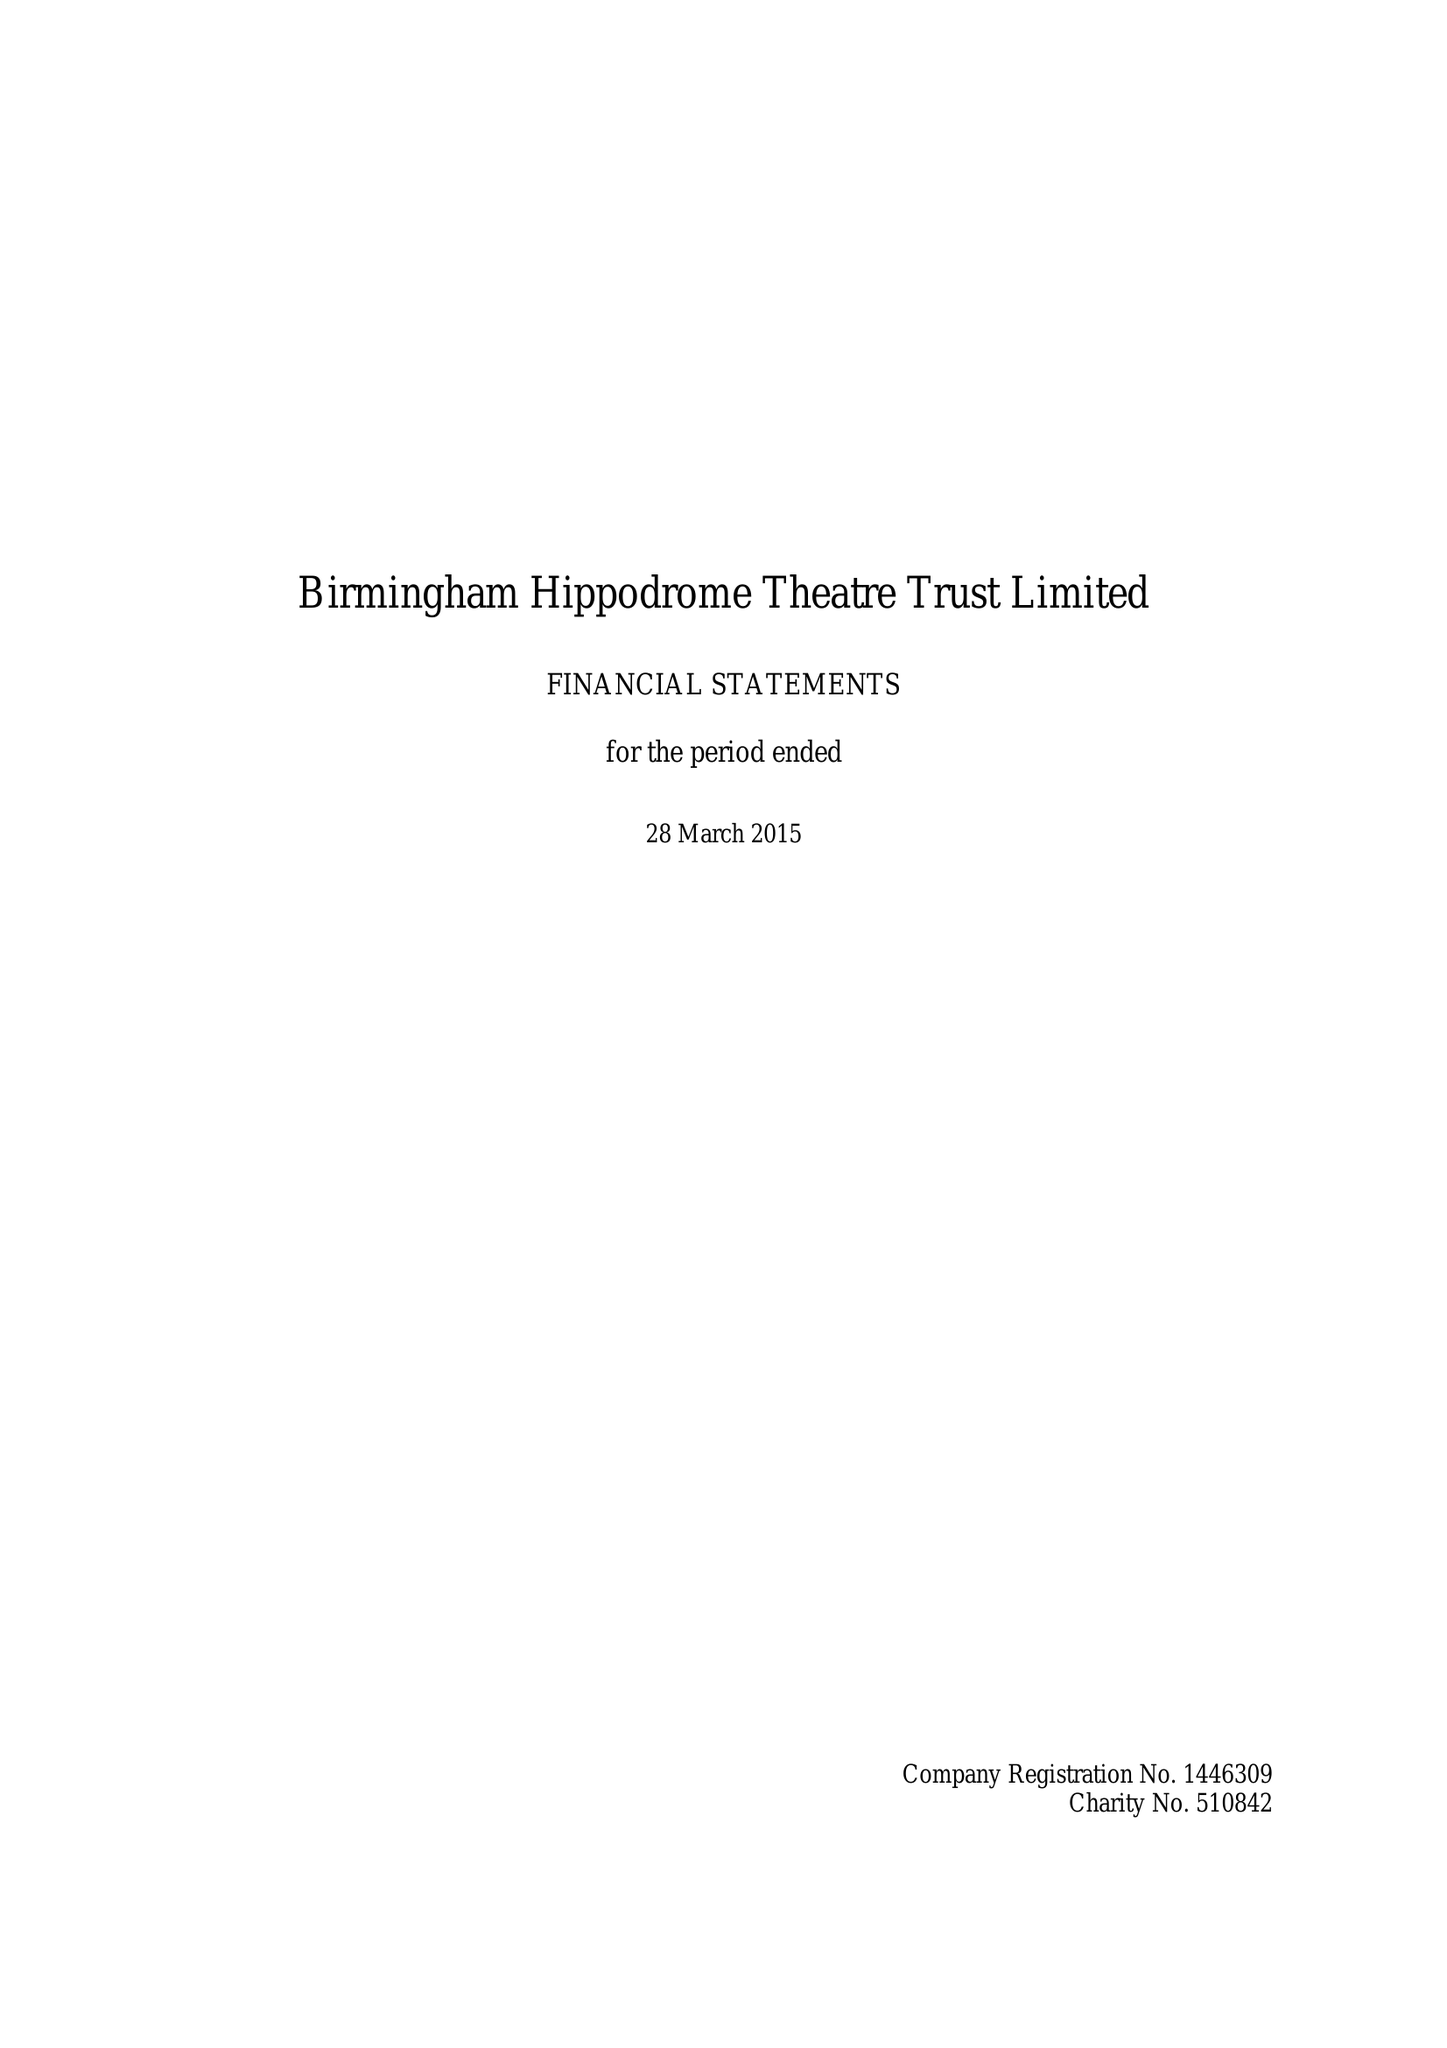What is the value for the address__postcode?
Answer the question using a single word or phrase. B5 4TB 